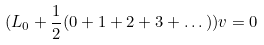Convert formula to latex. <formula><loc_0><loc_0><loc_500><loc_500>( L _ { 0 } + \frac { 1 } { 2 } ( 0 + 1 + 2 + 3 + \dots ) ) v = 0</formula> 